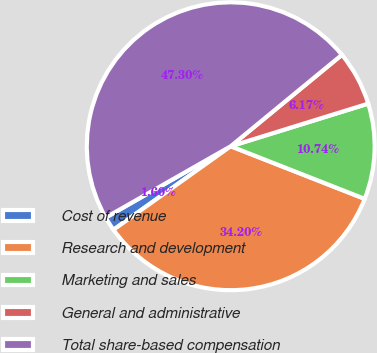Convert chart. <chart><loc_0><loc_0><loc_500><loc_500><pie_chart><fcel>Cost of revenue<fcel>Research and development<fcel>Marketing and sales<fcel>General and administrative<fcel>Total share-based compensation<nl><fcel>1.6%<fcel>34.2%<fcel>10.74%<fcel>6.17%<fcel>47.3%<nl></chart> 